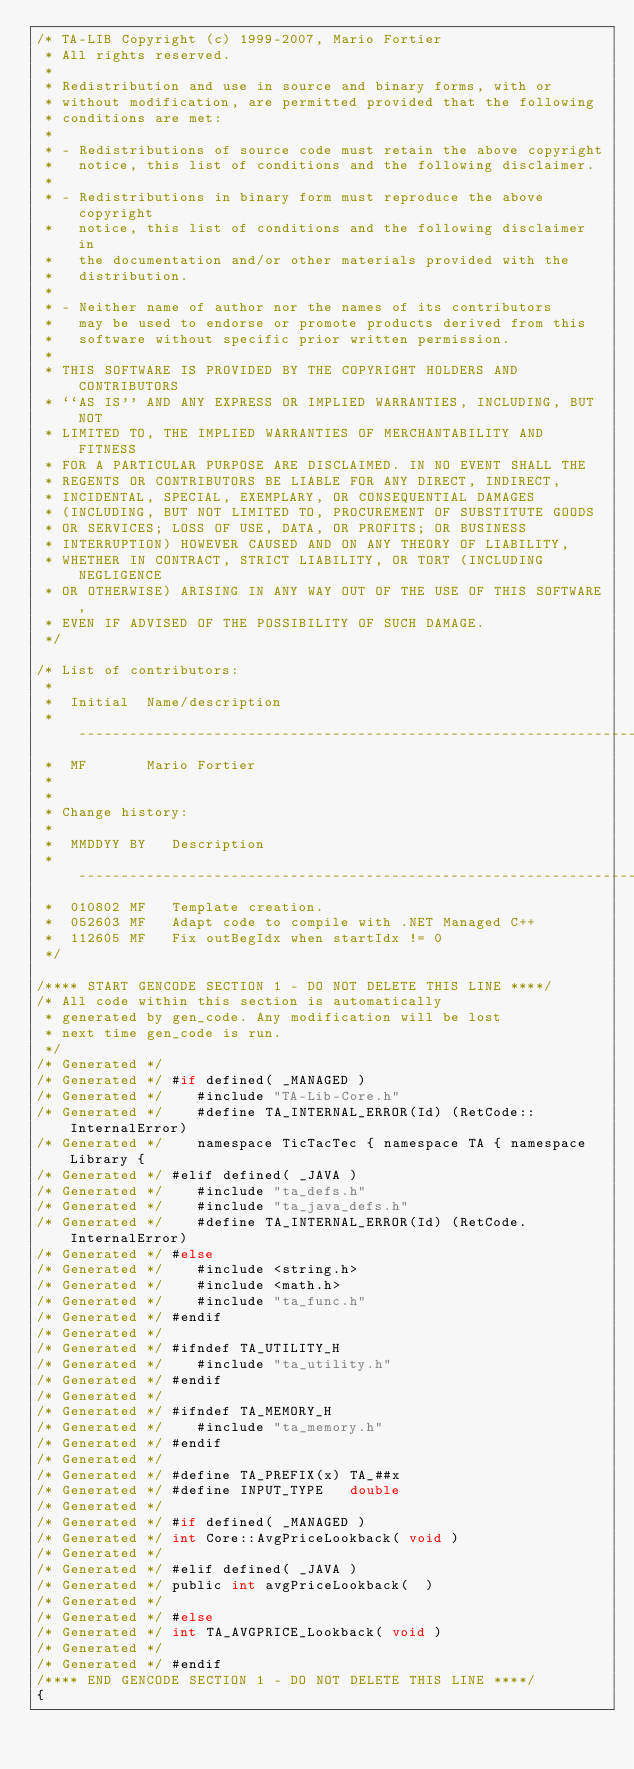Convert code to text. <code><loc_0><loc_0><loc_500><loc_500><_C_>/* TA-LIB Copyright (c) 1999-2007, Mario Fortier
 * All rights reserved.
 *
 * Redistribution and use in source and binary forms, with or
 * without modification, are permitted provided that the following
 * conditions are met:
 *
 * - Redistributions of source code must retain the above copyright
 *   notice, this list of conditions and the following disclaimer.
 *
 * - Redistributions in binary form must reproduce the above copyright
 *   notice, this list of conditions and the following disclaimer in
 *   the documentation and/or other materials provided with the
 *   distribution.
 *
 * - Neither name of author nor the names of its contributors
 *   may be used to endorse or promote products derived from this
 *   software without specific prior written permission.
 *
 * THIS SOFTWARE IS PROVIDED BY THE COPYRIGHT HOLDERS AND CONTRIBUTORS
 * ``AS IS'' AND ANY EXPRESS OR IMPLIED WARRANTIES, INCLUDING, BUT NOT
 * LIMITED TO, THE IMPLIED WARRANTIES OF MERCHANTABILITY AND FITNESS
 * FOR A PARTICULAR PURPOSE ARE DISCLAIMED. IN NO EVENT SHALL THE
 * REGENTS OR CONTRIBUTORS BE LIABLE FOR ANY DIRECT, INDIRECT,
 * INCIDENTAL, SPECIAL, EXEMPLARY, OR CONSEQUENTIAL DAMAGES
 * (INCLUDING, BUT NOT LIMITED TO, PROCUREMENT OF SUBSTITUTE GOODS
 * OR SERVICES; LOSS OF USE, DATA, OR PROFITS; OR BUSINESS
 * INTERRUPTION) HOWEVER CAUSED AND ON ANY THEORY OF LIABILITY,
 * WHETHER IN CONTRACT, STRICT LIABILITY, OR TORT (INCLUDING NEGLIGENCE
 * OR OTHERWISE) ARISING IN ANY WAY OUT OF THE USE OF THIS SOFTWARE,
 * EVEN IF ADVISED OF THE POSSIBILITY OF SUCH DAMAGE.
 */

/* List of contributors:
 *
 *  Initial  Name/description
 *  -------------------------------------------------------------------
 *  MF       Mario Fortier
 *
 *
 * Change history:
 *
 *  MMDDYY BY   Description
 *  -------------------------------------------------------------------
 *  010802 MF   Template creation.
 *  052603 MF   Adapt code to compile with .NET Managed C++
 *  112605 MF   Fix outBegIdx when startIdx != 0
 */

/**** START GENCODE SECTION 1 - DO NOT DELETE THIS LINE ****/
/* All code within this section is automatically
 * generated by gen_code. Any modification will be lost
 * next time gen_code is run.
 */
/* Generated */ 
/* Generated */ #if defined( _MANAGED )
/* Generated */    #include "TA-Lib-Core.h"
/* Generated */    #define TA_INTERNAL_ERROR(Id) (RetCode::InternalError)
/* Generated */    namespace TicTacTec { namespace TA { namespace Library {
/* Generated */ #elif defined( _JAVA )
/* Generated */    #include "ta_defs.h"
/* Generated */    #include "ta_java_defs.h"
/* Generated */    #define TA_INTERNAL_ERROR(Id) (RetCode.InternalError)
/* Generated */ #else
/* Generated */    #include <string.h>
/* Generated */    #include <math.h>
/* Generated */    #include "ta_func.h"
/* Generated */ #endif
/* Generated */ 
/* Generated */ #ifndef TA_UTILITY_H
/* Generated */    #include "ta_utility.h"
/* Generated */ #endif
/* Generated */ 
/* Generated */ #ifndef TA_MEMORY_H
/* Generated */    #include "ta_memory.h"
/* Generated */ #endif
/* Generated */ 
/* Generated */ #define TA_PREFIX(x) TA_##x
/* Generated */ #define INPUT_TYPE   double
/* Generated */ 
/* Generated */ #if defined( _MANAGED )
/* Generated */ int Core::AvgPriceLookback( void )
/* Generated */ 
/* Generated */ #elif defined( _JAVA )
/* Generated */ public int avgPriceLookback(  )
/* Generated */ 
/* Generated */ #else
/* Generated */ int TA_AVGPRICE_Lookback( void )
/* Generated */ 
/* Generated */ #endif
/**** END GENCODE SECTION 1 - DO NOT DELETE THIS LINE ****/
{</code> 